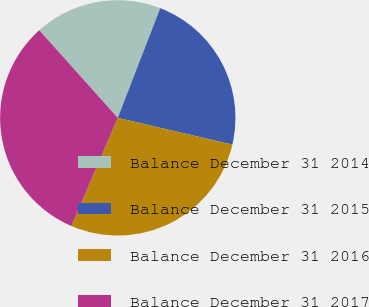<chart> <loc_0><loc_0><loc_500><loc_500><pie_chart><fcel>Balance December 31 2014<fcel>Balance December 31 2015<fcel>Balance December 31 2016<fcel>Balance December 31 2017<nl><fcel>17.51%<fcel>22.77%<fcel>27.8%<fcel>31.92%<nl></chart> 